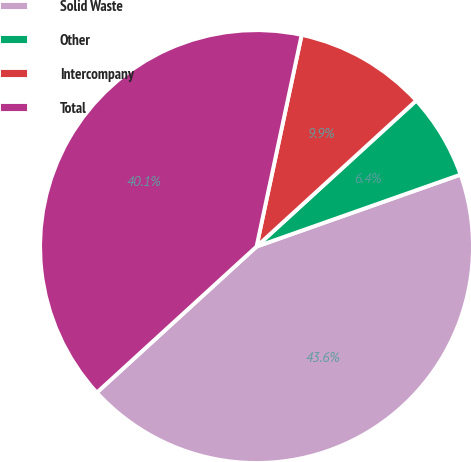<chart> <loc_0><loc_0><loc_500><loc_500><pie_chart><fcel>Solid Waste<fcel>Other<fcel>Intercompany<fcel>Total<nl><fcel>43.61%<fcel>6.39%<fcel>9.87%<fcel>40.13%<nl></chart> 